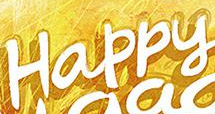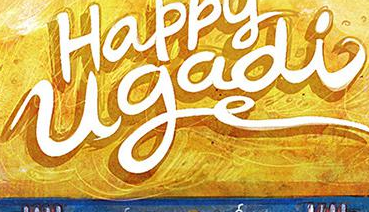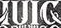Read the text content from these images in order, separated by a semicolon. Happy; ugadi; IUIC 